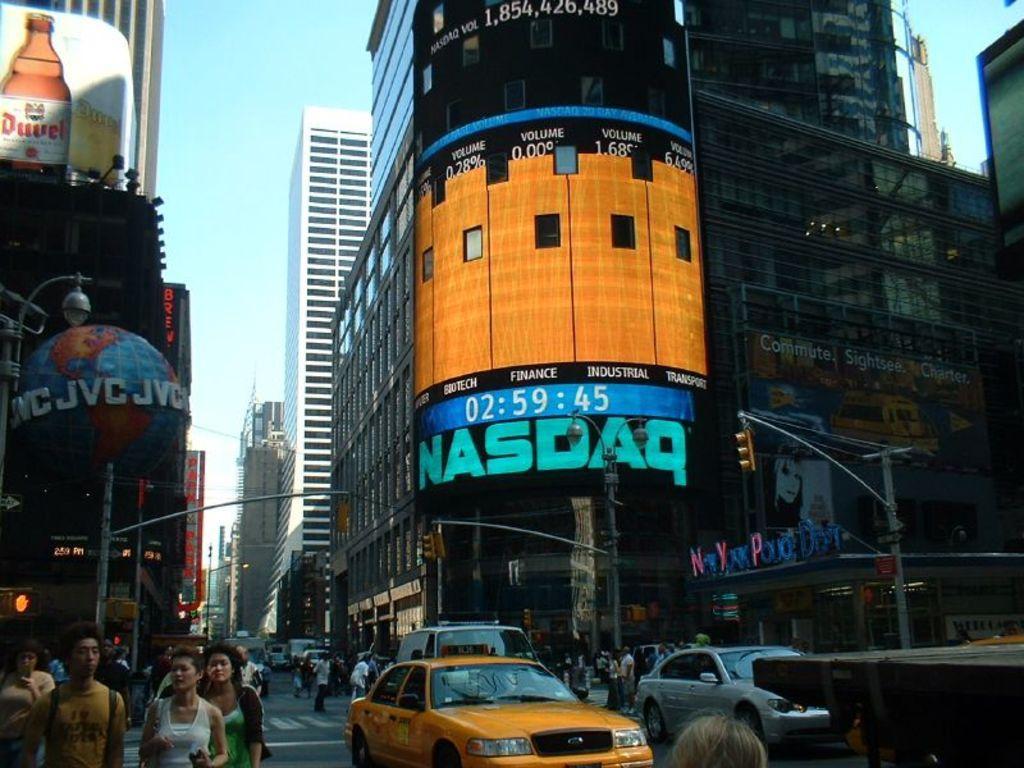Could you give a brief overview of what you see in this image? This image consists of buildings and skyscrapers. At the bottom, there is a road. On which there are cars and many people walking. At the top, there is a sky. 